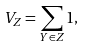<formula> <loc_0><loc_0><loc_500><loc_500>V _ { Z } = \sum _ { { Y } \in { Z } } 1 ,</formula> 